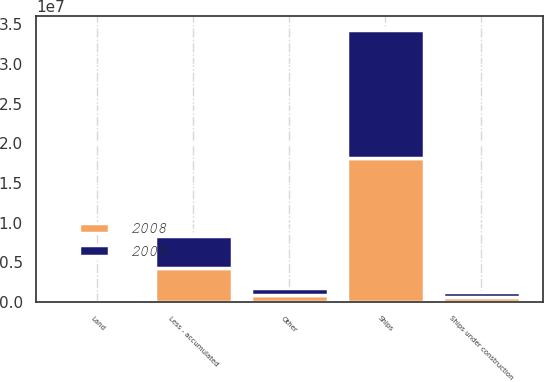Convert chart. <chart><loc_0><loc_0><loc_500><loc_500><stacked_bar_chart><ecel><fcel>Land<fcel>Ships<fcel>Ships under construction<fcel>Other<fcel>Less - accumulated<nl><fcel>2008<fcel>16688<fcel>1.8101e+07<fcel>562530<fcel>880188<fcel>4.29235e+06<nl><fcel>2009<fcel>16288<fcel>1.62148e+07<fcel>749822<fcel>862129<fcel>3.96407e+06<nl></chart> 